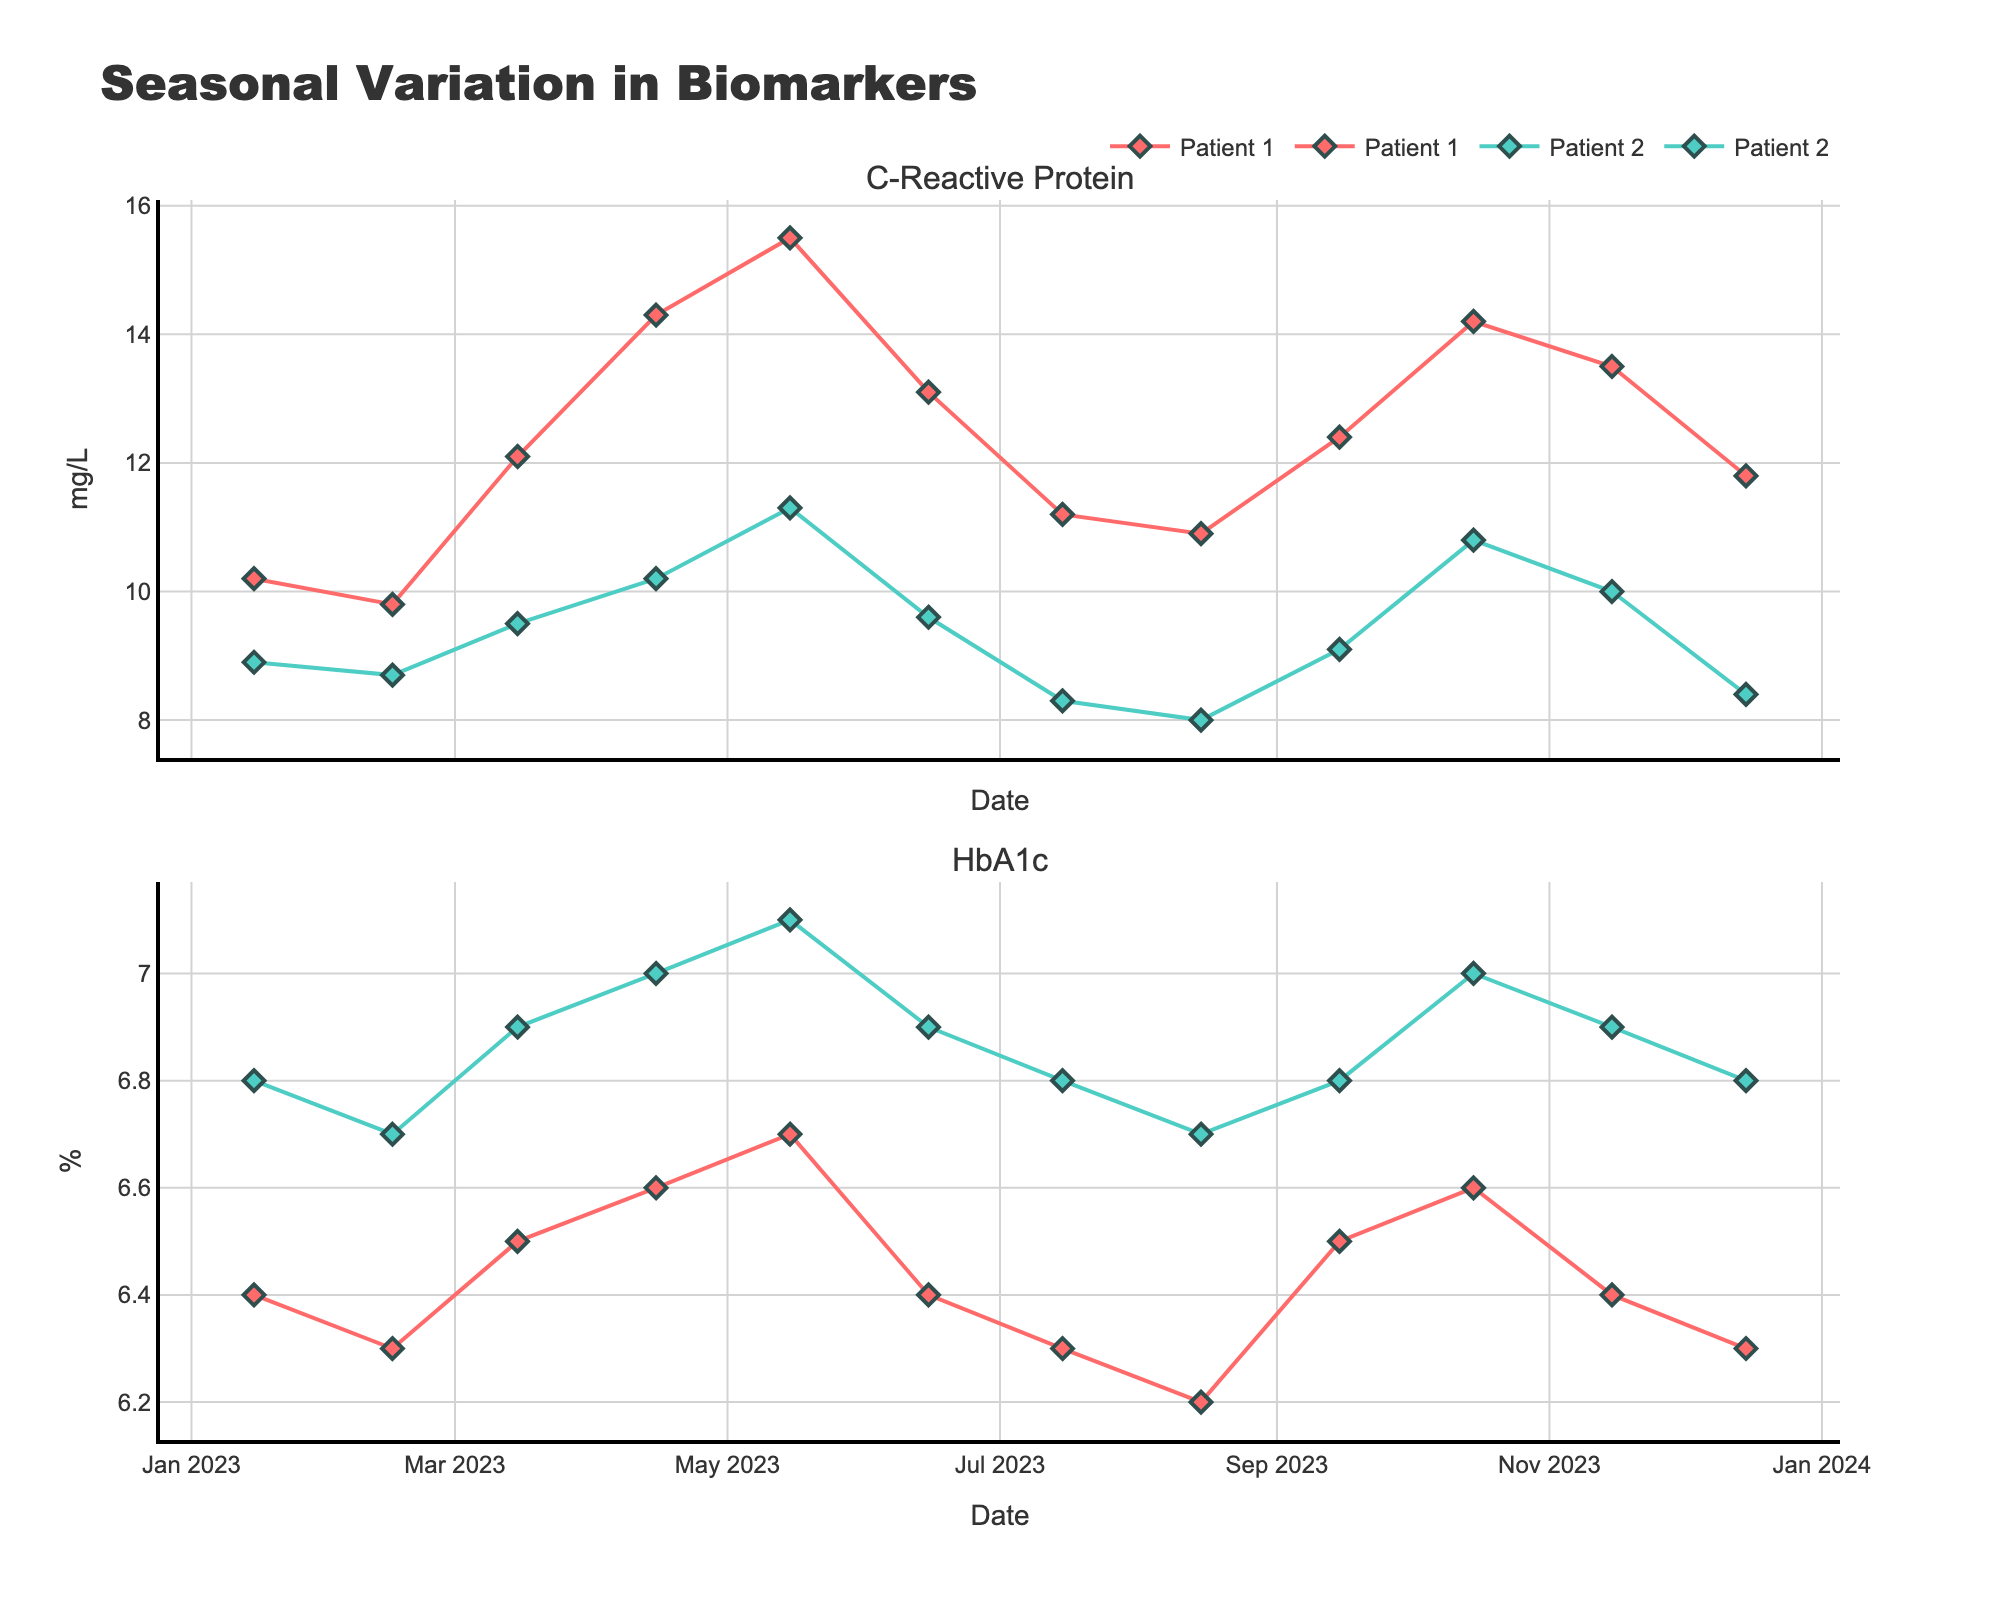What is the title of the figure? The title is usually placed at the top of the figure and summarizes the content in a descriptive manner. In this figure, it is "Seasonal Variation in Biomarkers".
Answer: Seasonal Variation in Biomarkers Which biomarker shows a clear increasing trend between April and May in both patients? Look at the plot corresponding to each biomarker between April and May. Both C-Reactive Protein traces for patients 1 and 2 increase from April to May.
Answer: C-Reactive Protein Which patient has higher C-Reactive Protein levels during peak months? By visually comparing the peaks of the two patients in the C-Reactive Protein subplot, Patient 1 consistently has higher values around peak months.
Answer: Patient 1 What is the average HbA1c level for Patient 1 in the first quarter of the year? The first quarter includes January, February, and March. Look at the HbA1c values for Patient 1 in these months: (6.4 + 6.3 + 6.5) / 3 = 6.4.
Answer: 6.4 Compare the December values of C-Reactive Protein for both patients. Who has a higher value? Examine the data points for December in the C-Reactive Protein subplot. Patient 1 has 11.8, while Patient 2 has 8.4. Hence, Patient 1 has a higher value.
Answer: Patient 1 What are the trough months for HbA1c levels in Patient 2? Identify the lowest points or troughs in the HbA1c subplot for Patient 2. HbA1c is lowest in January, February, and August (6.8, 6.7, and 6.7, respectively).
Answer: January, February, August How does the seasonal variation of C-Reactive Protein compare between the two patients? For both patients, C-Reactive Protein values rise towards the middle of the year (April-May) and decrease towards the end of the year with similar patterns, although Patient 1's levels are generally higher.
Answer: Similar trends, higher for Patient 1 What is the change in HbA1c levels for Patient 1 from January to December? Calculate the difference between the HbA1c values in January and December for Patient 1. January value is 6.4 and December is 6.3, resulting in a change of 6.3 - 6.4 = -0.1.
Answer: -0.1 Which month shows the highest C-Reactive Protein level for Patient 2, and what is the value? Look for the peak value in the C-Reactive Protein plot for Patient 2. The highest level is in May, with a value of 11.3.
Answer: May, 11.3 